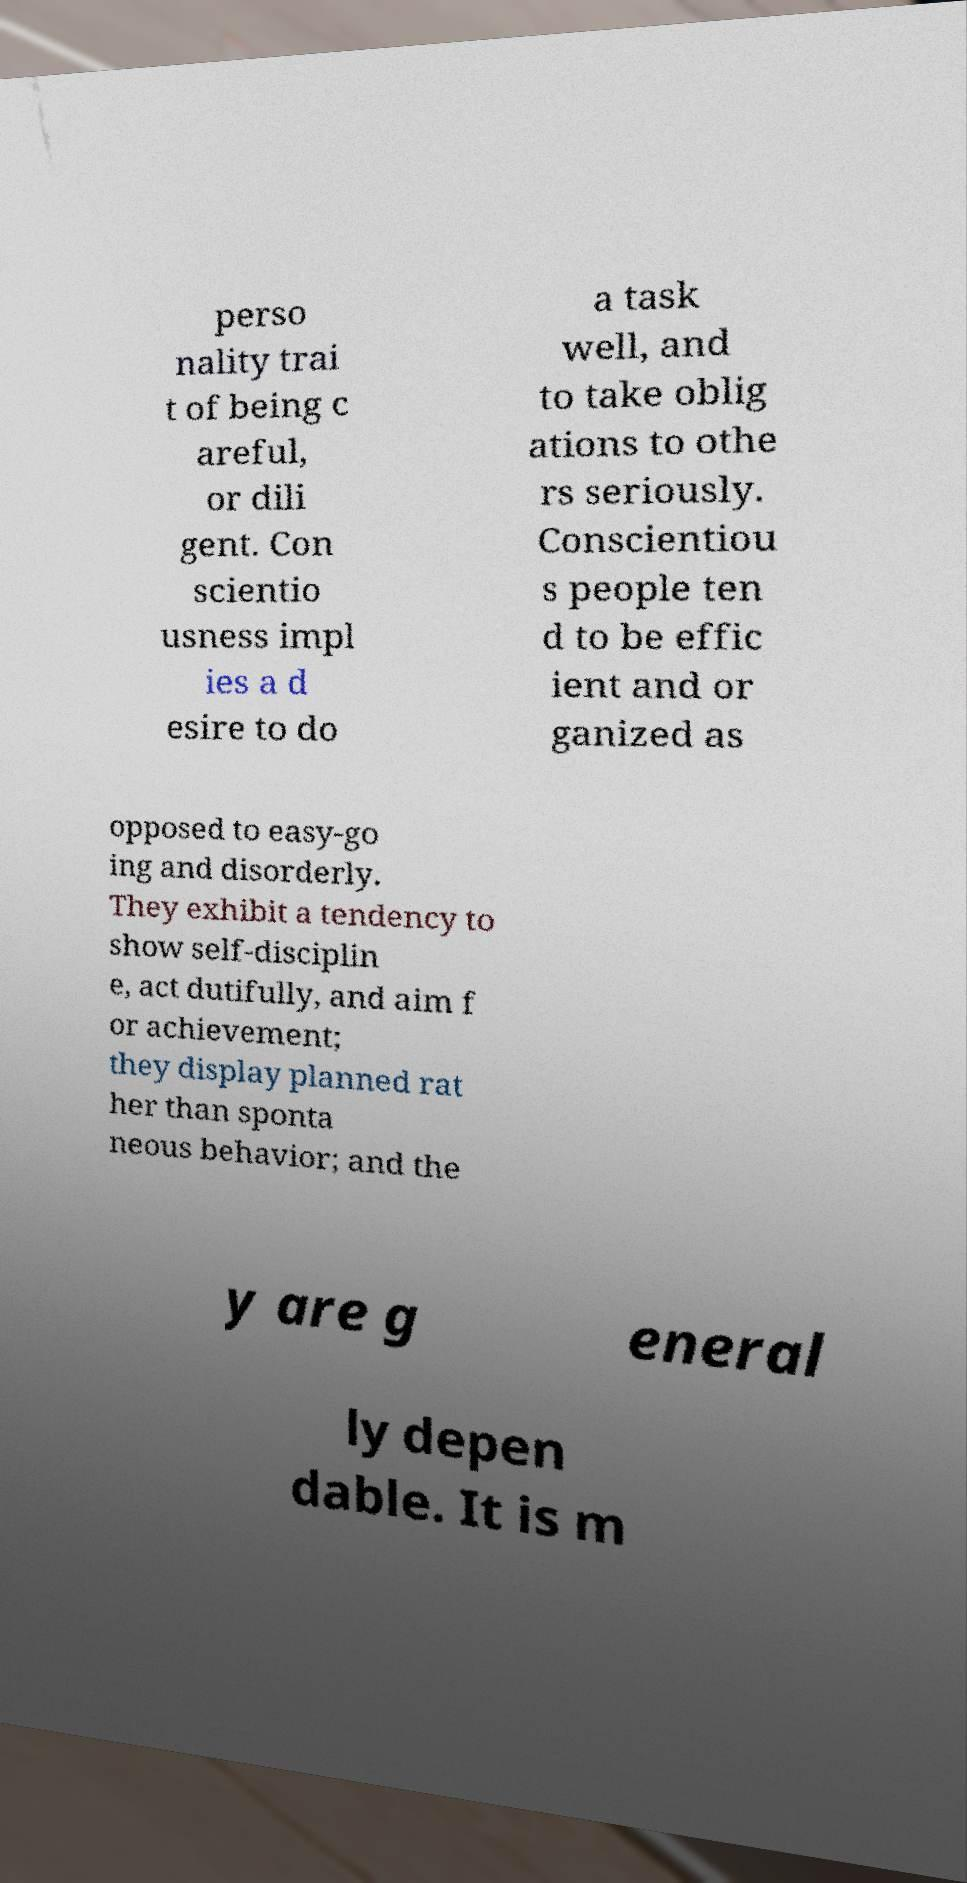Can you accurately transcribe the text from the provided image for me? perso nality trai t of being c areful, or dili gent. Con scientio usness impl ies a d esire to do a task well, and to take oblig ations to othe rs seriously. Conscientiou s people ten d to be effic ient and or ganized as opposed to easy-go ing and disorderly. They exhibit a tendency to show self-disciplin e, act dutifully, and aim f or achievement; they display planned rat her than sponta neous behavior; and the y are g eneral ly depen dable. It is m 